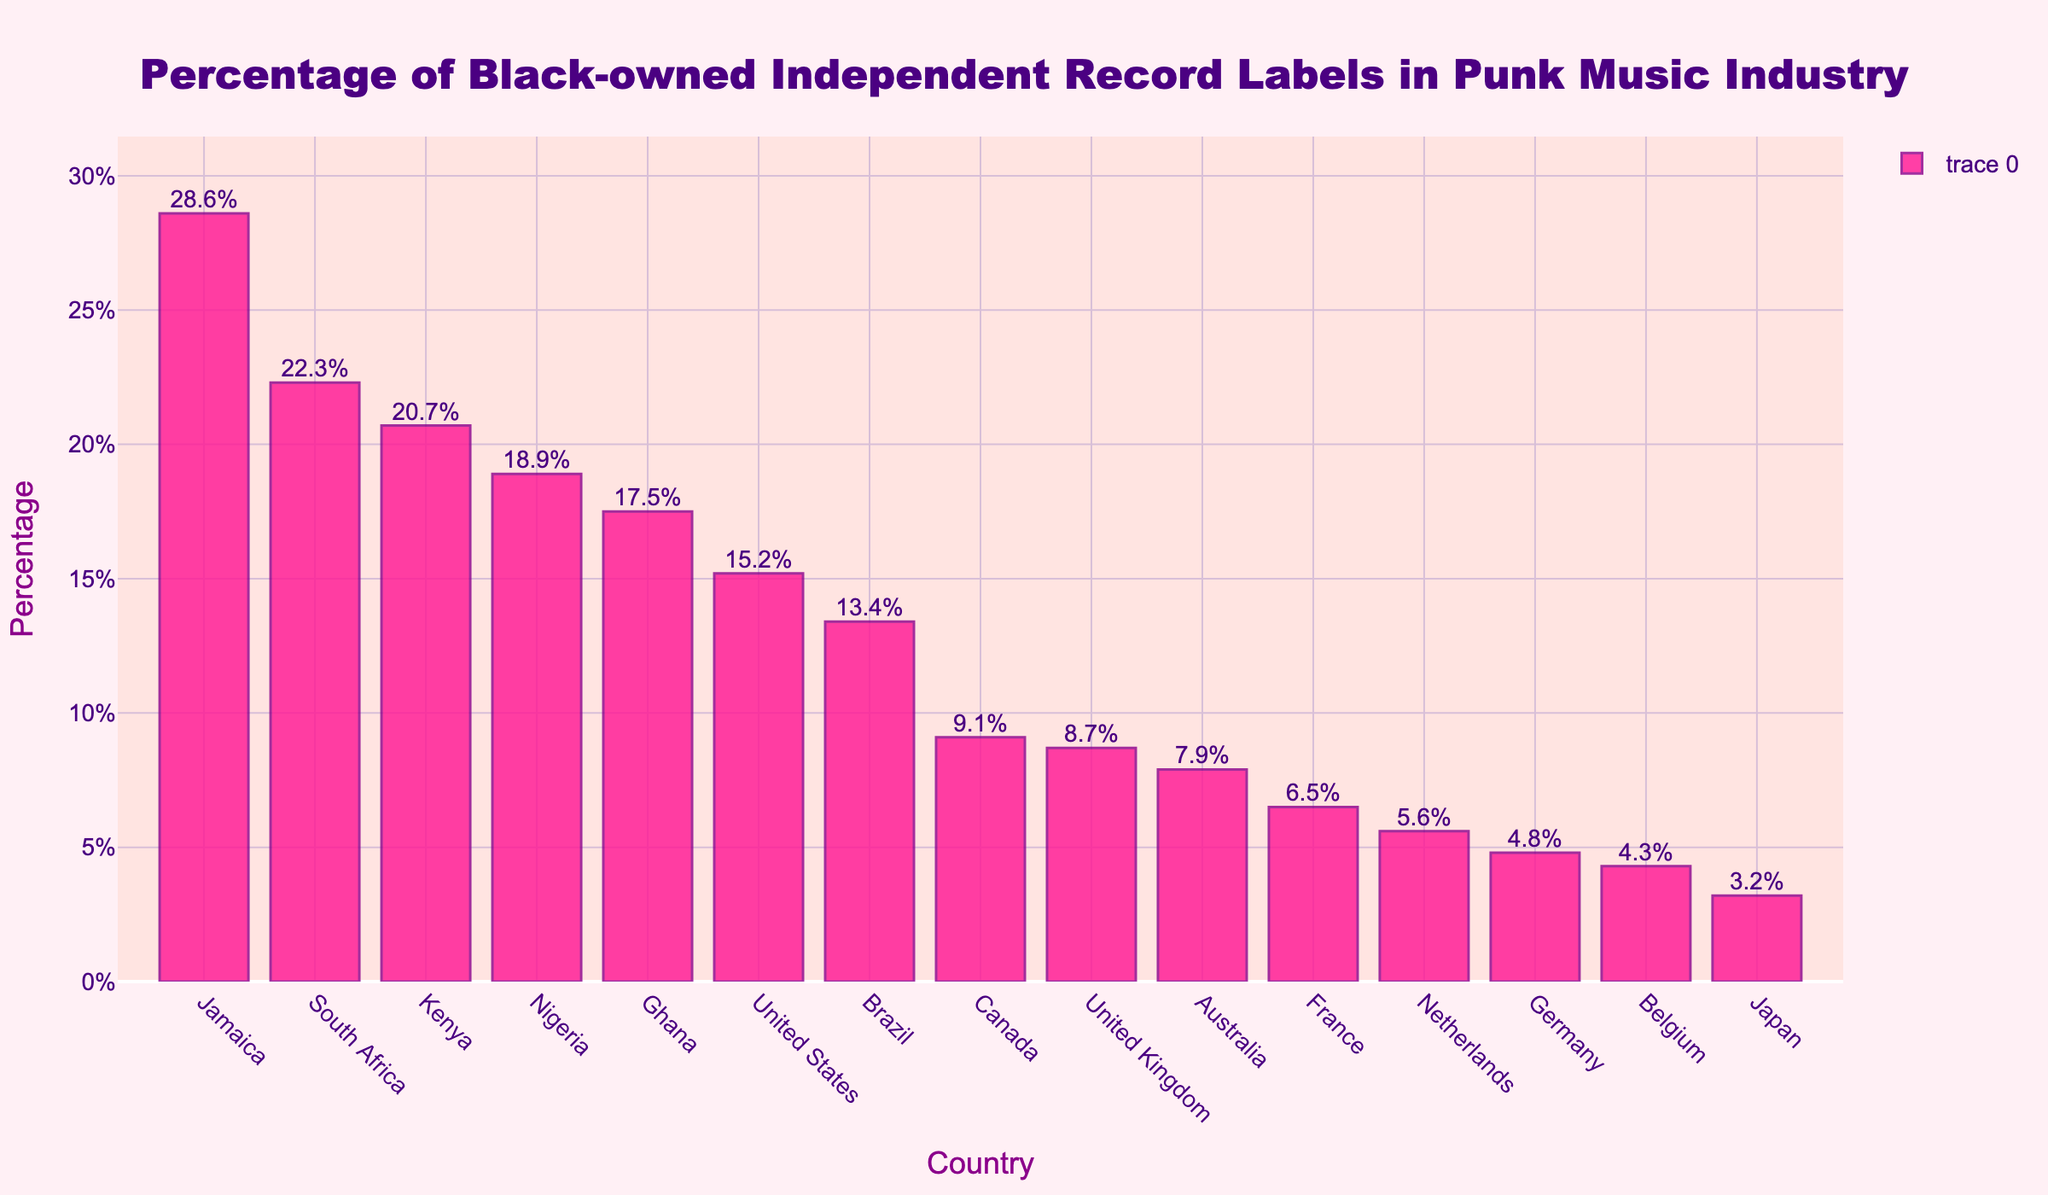Which country has the highest percentage of Black-owned independent record labels in the punk music industry? Look at the top of the bars to find the highest value. The highest bar represents Jamaica with a percentage of 28.6%.
Answer: Jamaica Which country has the lowest percentage of Black-owned independent record labels in the punk music industry? Look at the bottom of the bars to find the lowest value. The lowest bar represents Japan with a percentage of 3.2%.
Answer: Japan Compare the percentage of Black-owned independent record labels in South Africa and Kenya. Which country has a higher percentage? Identify and compare the heights of the bars for South Africa and Kenya. South Africa has a percentage of 22.3%, which is higher than Kenya's 20.7%.
Answer: South Africa What is the sum of the percentages for Nigeria and Ghana? Add the percentages of Nigeria (18.9%) and Ghana (17.5%) together. 18.9 + 17.5 = 36.4%.
Answer: 36.4% What is the average percentage of Black-owned independent record labels in the surveyed countries? Calculate the sum of the percentages of all countries and then divide by the number of countries (15). Sum is 206.7, so the average is 206.7 / 15 ≈ 13.78%.
Answer: 13.78% How much higher is Jamaica's percentage compared to Germany's? Subtract Germany's percentage (4.8%) from Jamaica’s percentage (28.6%). 28.6 - 4.8 = 23.8%.
Answer: 23.8% Which countries have a percentage higher than the overall average percentage calculated? Identify countries with percentages higher than the average of 13.78%. Those countries are South Africa, Nigeria, Jamaica, Kenya, Ghana, and United States.
Answer: South Africa, Nigeria, Jamaica, Kenya, Ghana, United States Compare the combined percentage of Black-owned independent record labels in the United States and the United Kingdom to Jamaica alone. Which is higher? Sum the percentages of the United States (15.2%) and the United Kingdom (8.7%), then compare to Jamaica’s (28.6%). 15.2 + 8.7 = 23.9%, which is lower than 28.6%.
Answer: Jamaica What is the median percentage of Black-owned independent record labels in the surveyed countries? Order the percentages and find the middle value. Ordered percentages: 3.2, 4.3, 4.8, 5.6, 6.5, 7.9, 8.7, 9.1, 13.4, 15.2, 17.5, 18.9, 20.7, 22.3, 28.6. The middle value (8th in order) is 9.1%.
Answer: 9.1% What is the percentage difference between the highest and lowest countries represented in the figure? Subtract the lowest percentage (Japan, 3.2%) from the highest percentage (Jamaica, 28.6%). 28.6 - 3.2 = 25.4%.
Answer: 25.4% 